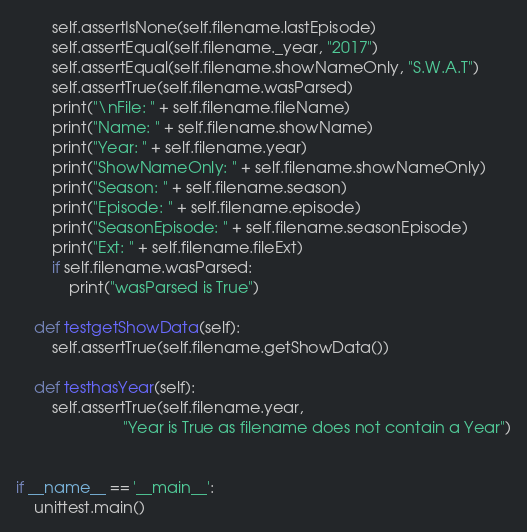<code> <loc_0><loc_0><loc_500><loc_500><_Python_>        self.assertIsNone(self.filename.lastEpisode)
        self.assertEqual(self.filename._year, "2017")
        self.assertEqual(self.filename.showNameOnly, "S.W.A.T")
        self.assertTrue(self.filename.wasParsed)
        print("\nFile: " + self.filename.fileName)
        print("Name: " + self.filename.showName)
        print("Year: " + self.filename.year)
        print("ShowNameOnly: " + self.filename.showNameOnly)
        print("Season: " + self.filename.season)
        print("Episode: " + self.filename.episode)
        print("SeasonEpisode: " + self.filename.seasonEpisode)
        print("Ext: " + self.filename.fileExt)
        if self.filename.wasParsed:
            print("wasParsed is True")

    def testgetShowData(self):
        self.assertTrue(self.filename.getShowData())

    def testhasYear(self):
        self.assertTrue(self.filename.year,
                        "Year is True as filename does not contain a Year")


if __name__ == '__main__':
    unittest.main()
</code> 